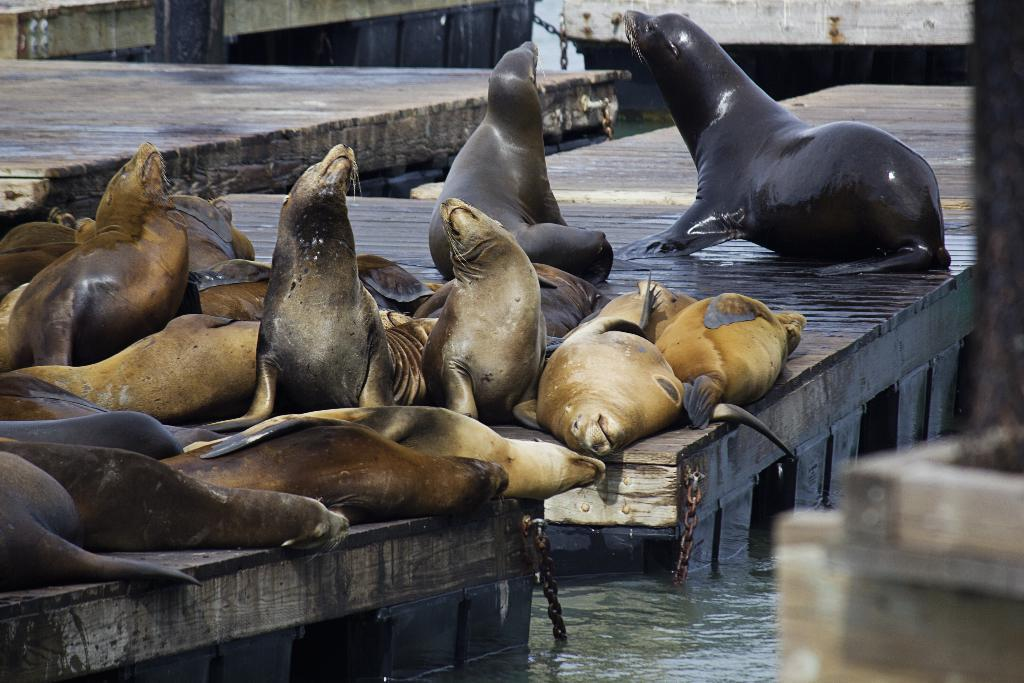What animals are present in the image? There are sea lions in the image. Where are the sea lions located? The sea lions are sitting on a bridge. What is the location of the bridge in the image? The bridge is on water. What is the price of the amusement ride in the image? There is no amusement ride present in the image, so it is not possible to determine its price. 